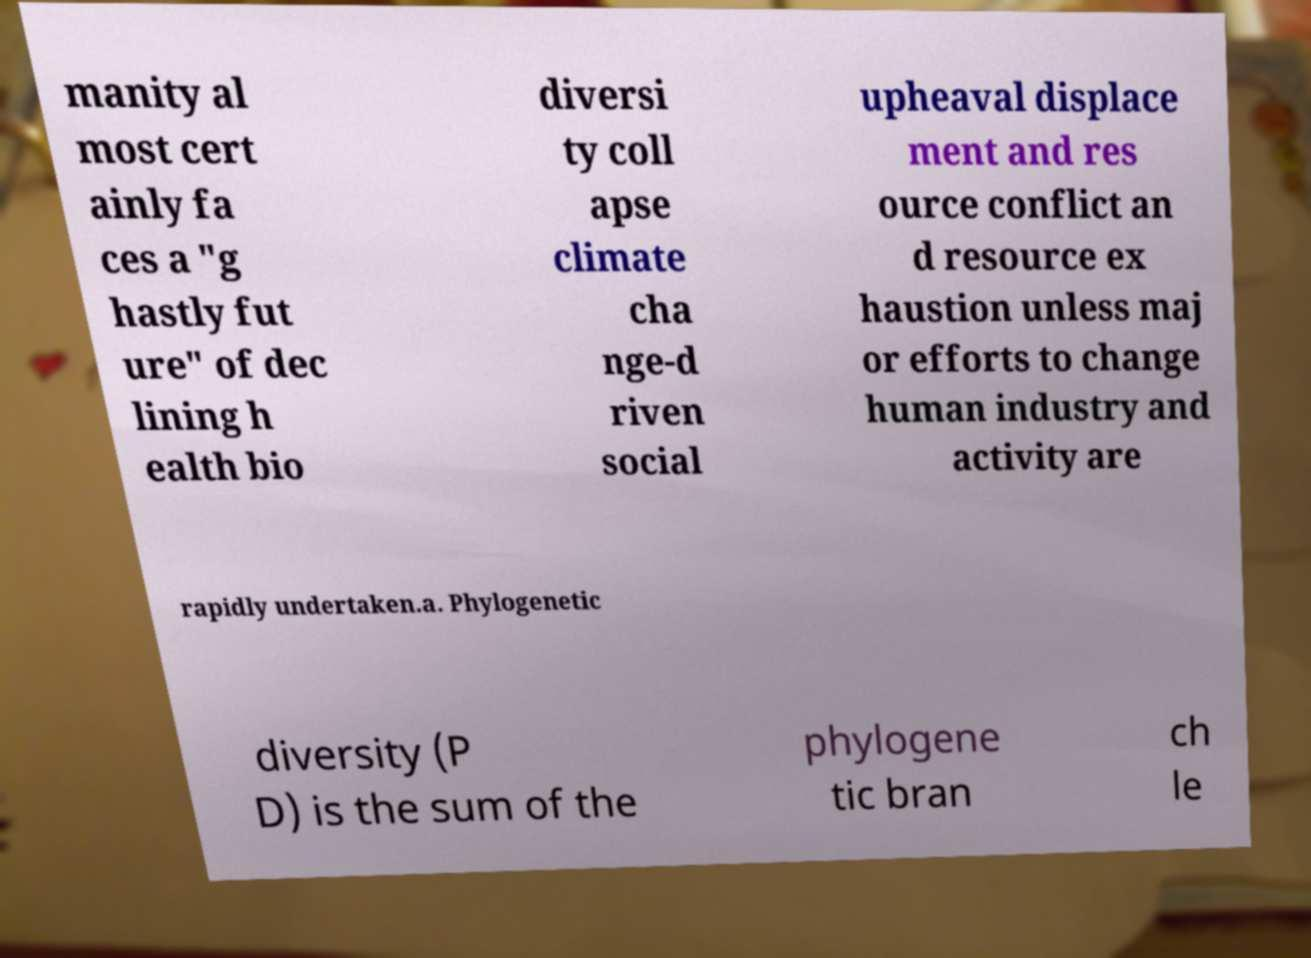Please identify and transcribe the text found in this image. manity al most cert ainly fa ces a "g hastly fut ure" of dec lining h ealth bio diversi ty coll apse climate cha nge-d riven social upheaval displace ment and res ource conflict an d resource ex haustion unless maj or efforts to change human industry and activity are rapidly undertaken.a. Phylogenetic diversity (P D) is the sum of the phylogene tic bran ch le 